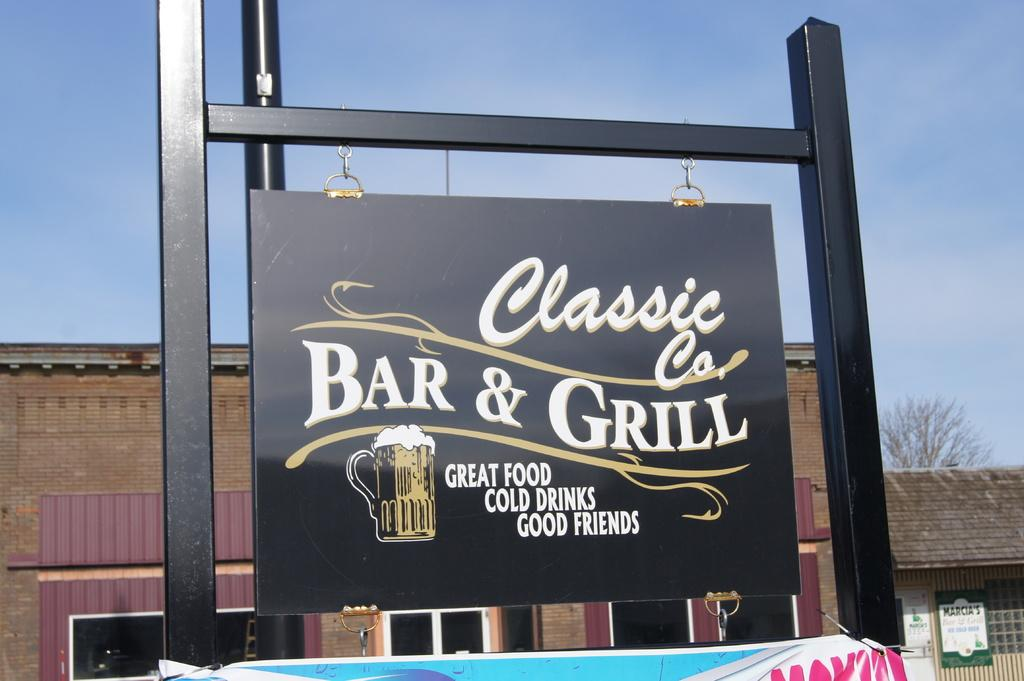<image>
Offer a succinct explanation of the picture presented. A sign saying: "Classic Bar & Grill" Greatfood, Cold Drinks, Good Friends. 